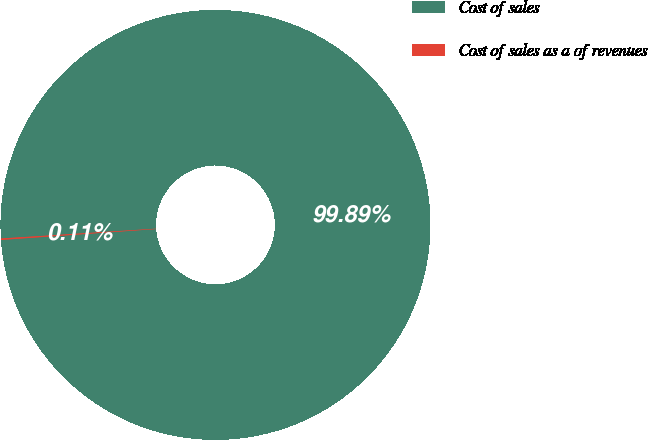<chart> <loc_0><loc_0><loc_500><loc_500><pie_chart><fcel>Cost of sales<fcel>Cost of sales as a of revenues<nl><fcel>99.89%<fcel>0.11%<nl></chart> 